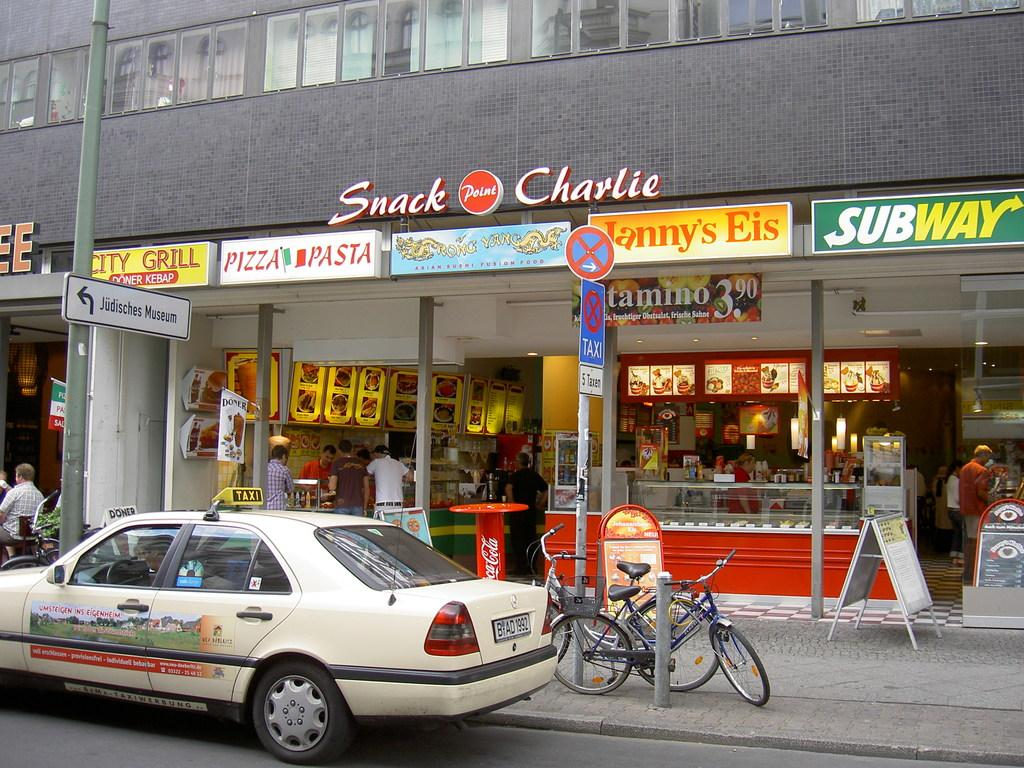<image>
Offer a succinct explanation of the picture presented. A side of road that has a Subway and a Pizza Pasta store. 